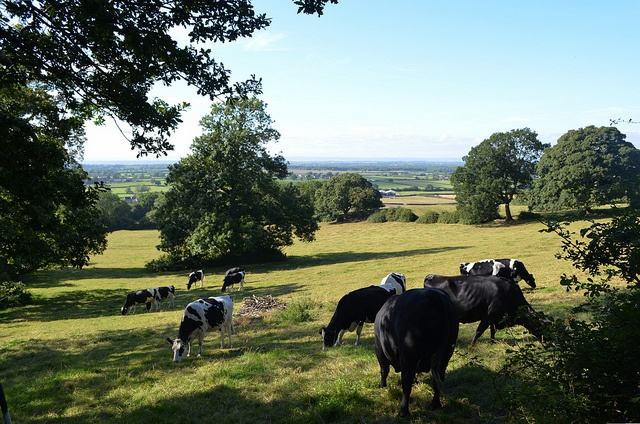Describe the objects in this image and their specific colors. I can see cow in blue, black, gray, darkgreen, and olive tones, cow in blue, black, gray, darkgreen, and olive tones, cow in blue, black, gray, and darkgreen tones, cow in blue, black, gray, darkgreen, and olive tones, and cow in blue, black, white, gray, and darkgray tones in this image. 